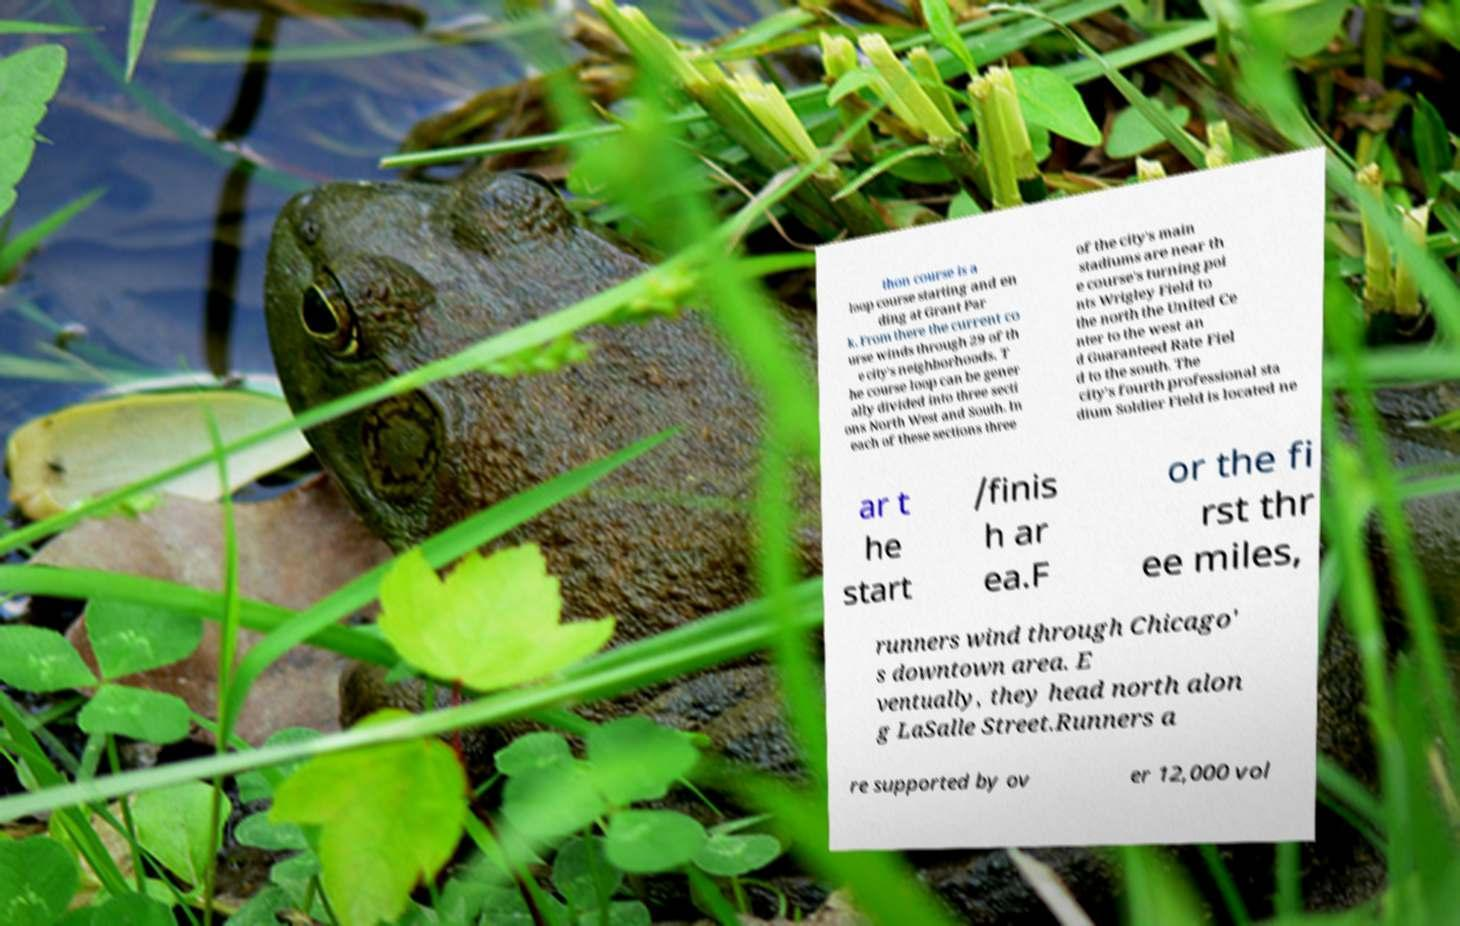Could you extract and type out the text from this image? thon course is a loop course starting and en ding at Grant Par k. From there the current co urse winds through 29 of th e city's neighborhoods. T he course loop can be gener ally divided into three secti ons North West and South. In each of these sections three of the city's main stadiums are near th e course's turning poi nts Wrigley Field to the north the United Ce nter to the west an d Guaranteed Rate Fiel d to the south. The city's fourth professional sta dium Soldier Field is located ne ar t he start /finis h ar ea.F or the fi rst thr ee miles, runners wind through Chicago' s downtown area. E ventually, they head north alon g LaSalle Street.Runners a re supported by ov er 12,000 vol 